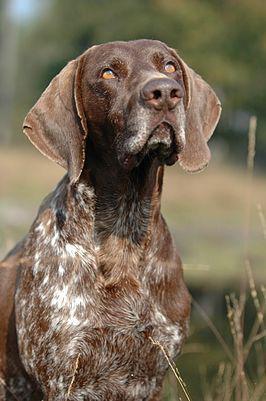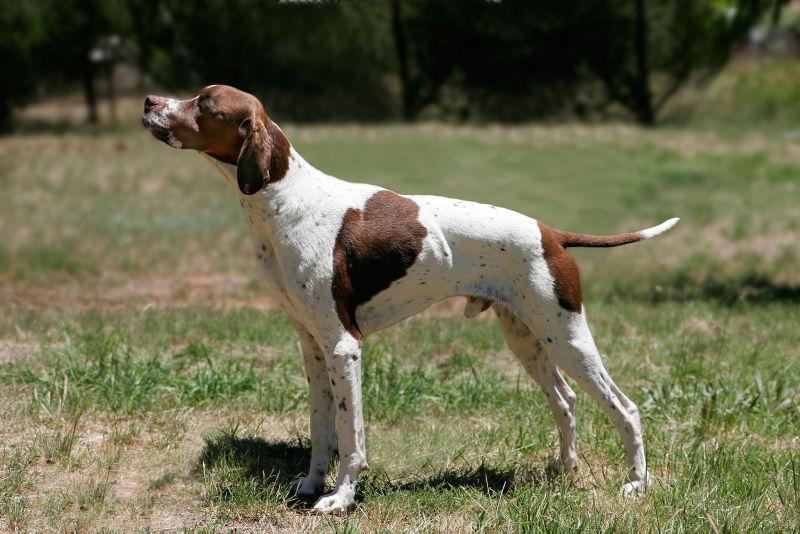The first image is the image on the left, the second image is the image on the right. Considering the images on both sides, is "At least one dog is sitting." valid? Answer yes or no. Yes. The first image is the image on the left, the second image is the image on the right. Given the left and right images, does the statement "The dog on the left is gazing leftward, and the dog on the right stands in profile with its body turned rightward." hold true? Answer yes or no. No. 